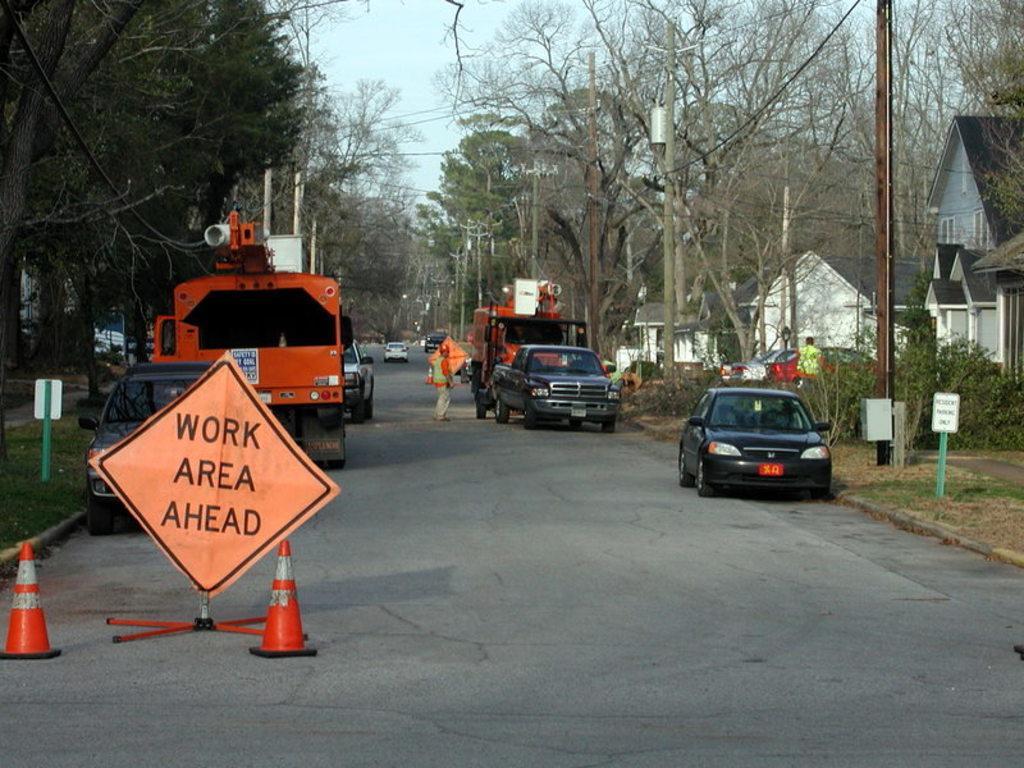How would you summarize this image in a sentence or two? In the picture there is a road, on the road there are many vehicles present, there are red color cones present, there is a board with the text, there are poles with the cables, there are plants, there are trees, there are buildings, there is a clear sky. 